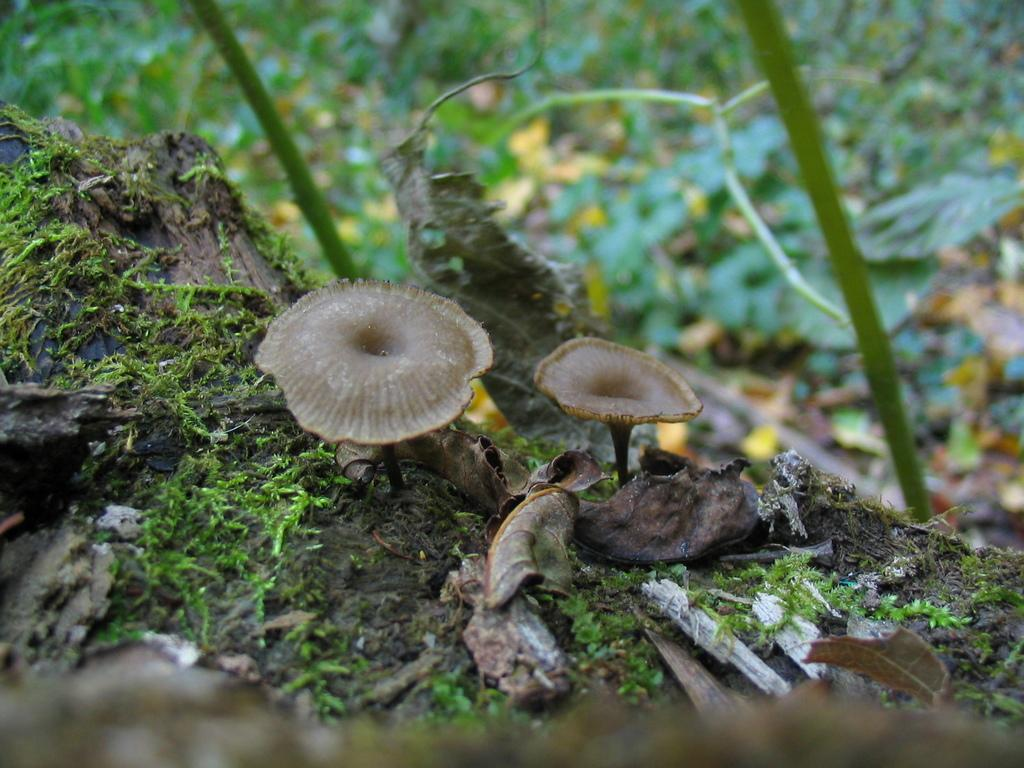What type of fungi can be seen in the image? There are two brown color mushrooms in the image. What type of vegetation is visible in the image? The grass is visible in the image. What additional natural elements can be seen in the image? Dry leaves are present in the image. How would you describe the background of the image? The background of the image is blurred. How many kittens are playing with the mushrooms in the image? There are no kittens present in the image; it only features mushrooms, grass, dry leaves, and a blurred background. 